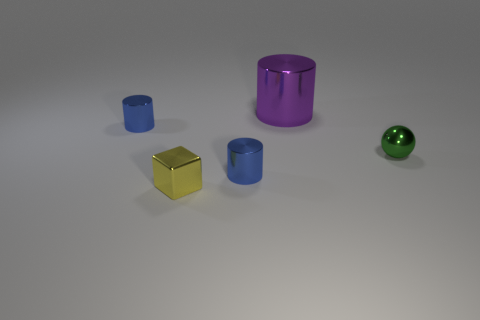Add 3 large cylinders. How many objects exist? 8 Subtract all blocks. How many objects are left? 4 Subtract 0 gray balls. How many objects are left? 5 Subtract all large cyan cylinders. Subtract all balls. How many objects are left? 4 Add 2 purple cylinders. How many purple cylinders are left? 3 Add 2 green metal things. How many green metal things exist? 3 